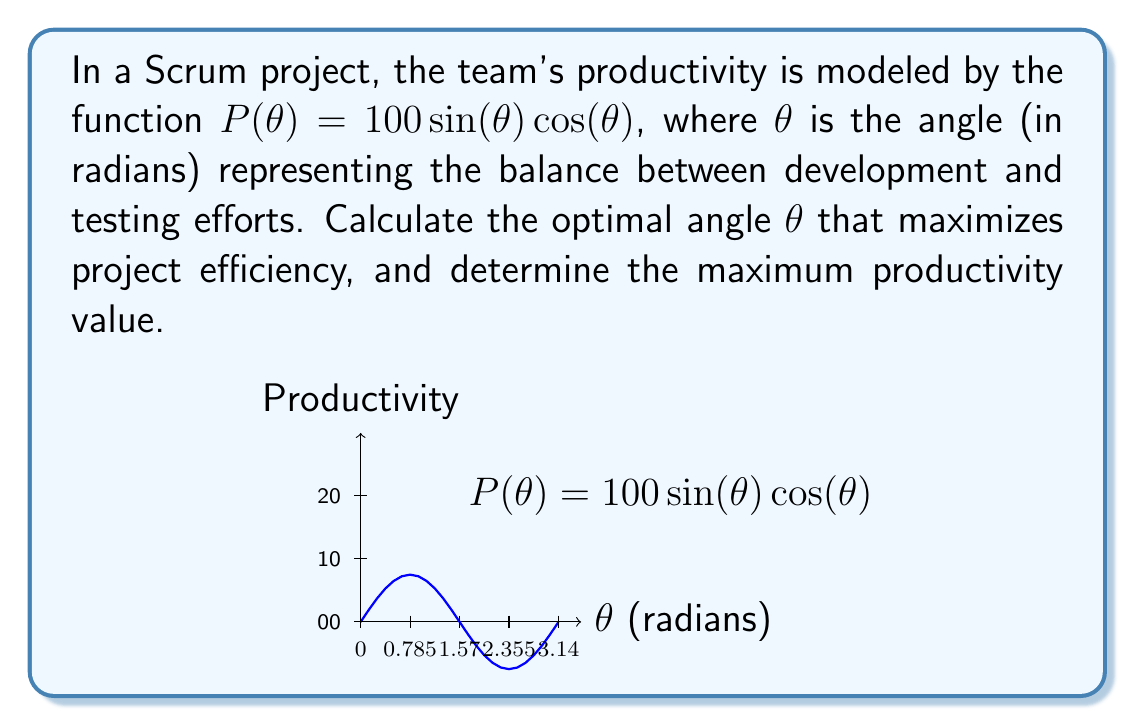Can you answer this question? To solve this problem, we'll follow these steps:

1) The productivity function is given by $P(\theta) = 100\sin(\theta)\cos(\theta)$. To find the maximum, we need to find where the derivative equals zero.

2) Let's simplify the function first using the trigonometric identity:
   $\sin(2\theta) = 2\sin(\theta)\cos(\theta)$
   
   So, $P(\theta) = 100\sin(\theta)\cos(\theta) = 50\sin(2\theta)$

3) Now, let's find the derivative:
   $P'(\theta) = 50 \cdot 2\cos(2\theta) = 100\cos(2\theta)$

4) Set the derivative to zero and solve:
   $100\cos(2\theta) = 0$
   $\cos(2\theta) = 0$
   
   This occurs when $2\theta = \frac{\pi}{2}$ or $\frac{3\pi}{2}$
   
   Therefore, $\theta = \frac{\pi}{4}$ or $\frac{3\pi}{4}$

5) To determine which gives the maximum, we can check the second derivative:
   $P''(\theta) = -200\sin(2\theta)$
   
   At $\theta = \frac{\pi}{4}$: $P''(\frac{\pi}{4}) = -200\sin(\frac{\pi}{2}) = -200 < 0$
   This confirms that $\theta = \frac{\pi}{4}$ gives a maximum.

6) The maximum productivity is:
   $P(\frac{\pi}{4}) = 50\sin(2 \cdot \frac{\pi}{4}) = 50\sin(\frac{\pi}{2}) = 50$

Therefore, the optimal angle for maximum project efficiency is $\frac{\pi}{4}$ radians (or 45°), and the maximum productivity value is 50.
Answer: Optimal angle: $\theta = \frac{\pi}{4}$ radians (45°)
Maximum productivity: 50 